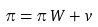Convert formula to latex. <formula><loc_0><loc_0><loc_500><loc_500>\pi = \pi \, W + v</formula> 